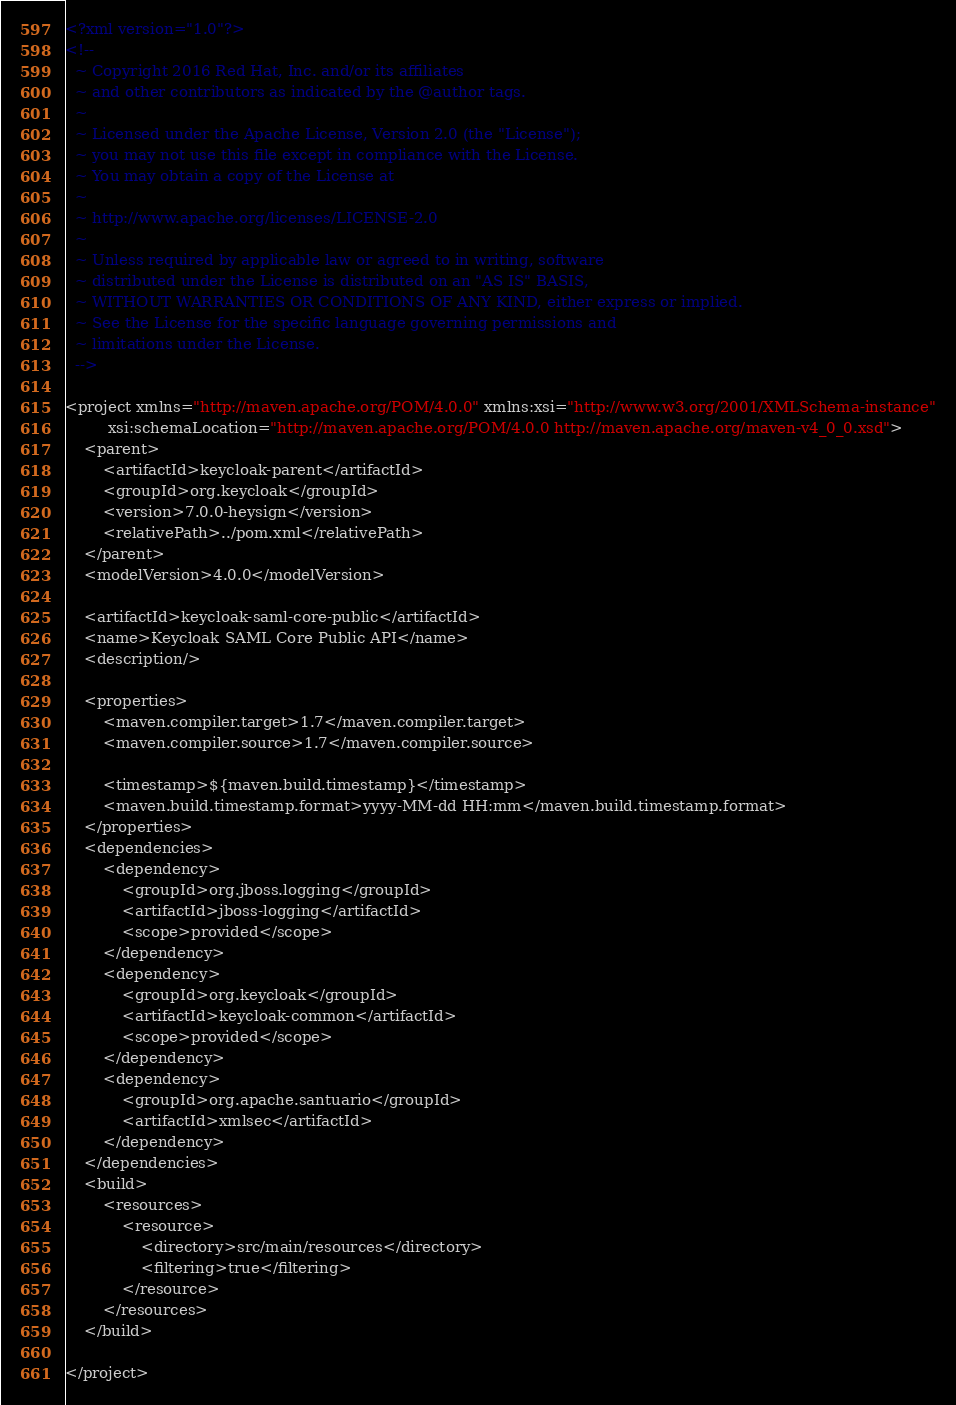Convert code to text. <code><loc_0><loc_0><loc_500><loc_500><_XML_><?xml version="1.0"?>
<!--
  ~ Copyright 2016 Red Hat, Inc. and/or its affiliates
  ~ and other contributors as indicated by the @author tags.
  ~
  ~ Licensed under the Apache License, Version 2.0 (the "License");
  ~ you may not use this file except in compliance with the License.
  ~ You may obtain a copy of the License at
  ~
  ~ http://www.apache.org/licenses/LICENSE-2.0
  ~
  ~ Unless required by applicable law or agreed to in writing, software
  ~ distributed under the License is distributed on an "AS IS" BASIS,
  ~ WITHOUT WARRANTIES OR CONDITIONS OF ANY KIND, either express or implied.
  ~ See the License for the specific language governing permissions and
  ~ limitations under the License.
  -->

<project xmlns="http://maven.apache.org/POM/4.0.0" xmlns:xsi="http://www.w3.org/2001/XMLSchema-instance"
         xsi:schemaLocation="http://maven.apache.org/POM/4.0.0 http://maven.apache.org/maven-v4_0_0.xsd">
    <parent>
        <artifactId>keycloak-parent</artifactId>
        <groupId>org.keycloak</groupId>
        <version>7.0.0-heysign</version>
        <relativePath>../pom.xml</relativePath>
    </parent>
    <modelVersion>4.0.0</modelVersion>

    <artifactId>keycloak-saml-core-public</artifactId>
    <name>Keycloak SAML Core Public API</name>
    <description/>

    <properties>
        <maven.compiler.target>1.7</maven.compiler.target>
        <maven.compiler.source>1.7</maven.compiler.source>

        <timestamp>${maven.build.timestamp}</timestamp>
        <maven.build.timestamp.format>yyyy-MM-dd HH:mm</maven.build.timestamp.format>
    </properties>
    <dependencies>
        <dependency>
            <groupId>org.jboss.logging</groupId>
            <artifactId>jboss-logging</artifactId>
            <scope>provided</scope>
        </dependency>
        <dependency>
            <groupId>org.keycloak</groupId>
            <artifactId>keycloak-common</artifactId>
            <scope>provided</scope>
        </dependency>
        <dependency>
            <groupId>org.apache.santuario</groupId>
            <artifactId>xmlsec</artifactId>
        </dependency>
    </dependencies>
    <build>
        <resources>
            <resource>
                <directory>src/main/resources</directory>
                <filtering>true</filtering>
            </resource>
        </resources>
    </build>

</project>
</code> 